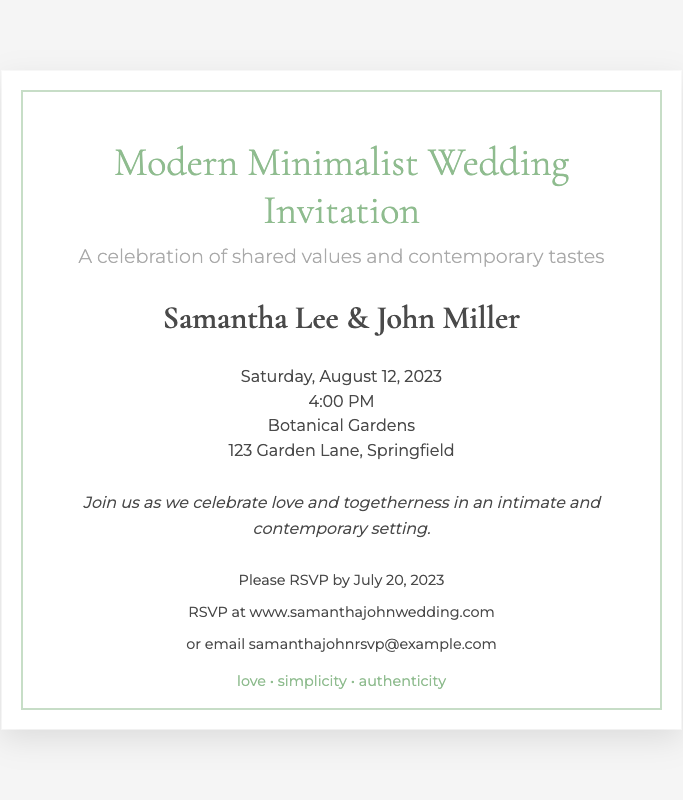What are the names of the couple? The names of the couple are clearly stated in the document as Samantha Lee and John Miller.
Answer: Samantha Lee & John Miller What is the date of the wedding? The date of the wedding is mentioned in the document. It is Saturday, August 12, 2023.
Answer: August 12, 2023 What time does the wedding ceremony start? The document specifies the time of the ceremony, which is 4:00 PM.
Answer: 4:00 PM Where is the wedding taking place? The location of the wedding can be found in the details section of the invitation. It is the Botanical Gardens.
Answer: Botanical Gardens What themes are highlighted in the invitation? The invitation includes specific values that the couple cherishes such as love, simplicity, and authenticity.
Answer: love • simplicity • authenticity What is the RSVP deadline? The RSVP deadline is explicitly stated in the document as July 20, 2023.
Answer: July 20, 2023 What style is the wedding invitation? The wedding invitation is described as Modern Minimalist, indicating its design style.
Answer: Modern Minimalist How should attendees RSVP to the wedding? Instructions on how to RSVP are provided in the document, including a website and an email address.
Answer: www.samanthajohnwedding.com or samanthajohnrsvp@example.com 